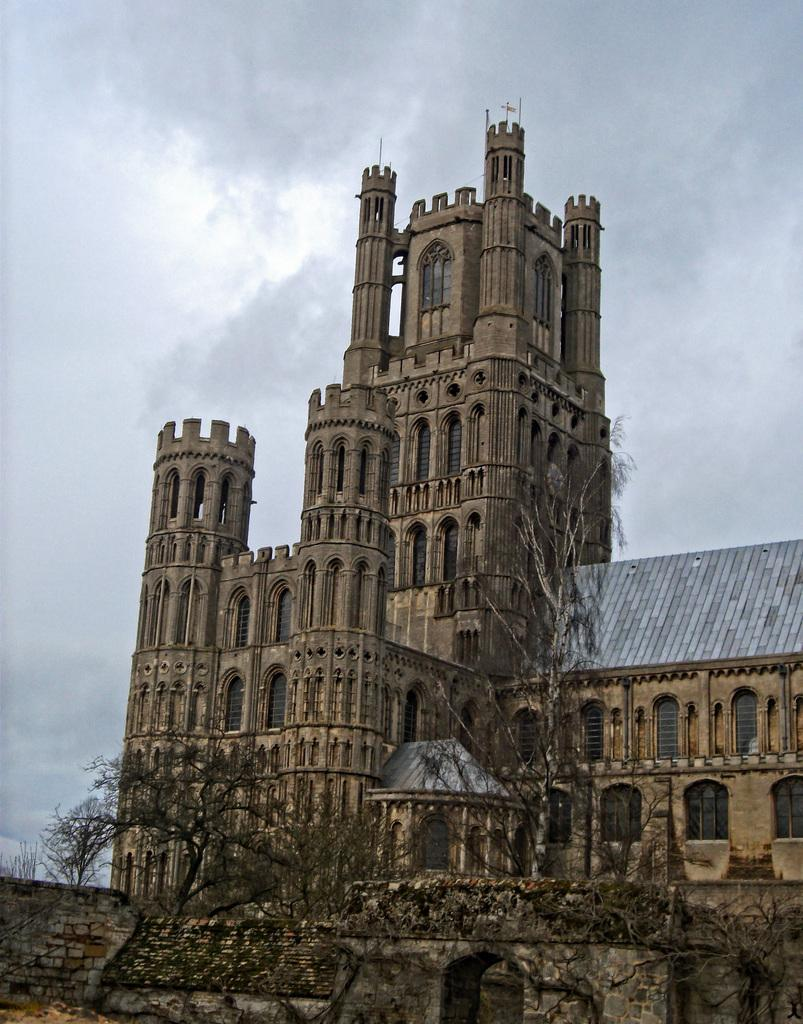What type of structure is present in the image? There is a building in the image. What features can be observed on the building? The building has windows, pillars, and a wall. What type of vegetation is present in the image? There are trees in the image. What can be seen in the background of the image? The sky with clouds is visible in the background of the image. What year is depicted in the image? The image does not depict a specific year; it is a photograph of a building, trees, and the sky. Can you see the moon in the image? No, the moon is not visible in the image; only the sky with clouds can be seen in the background. 